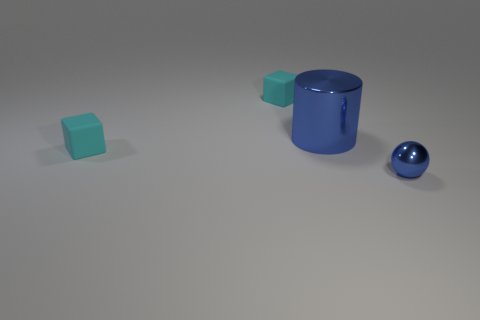How many other objects are the same material as the tiny blue thing?
Your response must be concise. 1. Is the number of blue balls that are on the left side of the tiny blue metallic sphere less than the number of large blue cylinders?
Your response must be concise. Yes. How many tiny cyan cubes are there?
Offer a terse response. 2. What number of big shiny objects are the same color as the large cylinder?
Your answer should be very brief. 0. Do the large blue metal thing and the small metallic object have the same shape?
Offer a very short reply. No. How big is the rubber block to the left of the matte object behind the blue cylinder?
Give a very brief answer. Small. Is there a matte object that has the same size as the blue sphere?
Ensure brevity in your answer.  Yes. There is a blue metallic thing behind the tiny sphere; does it have the same size as the rubber block in front of the shiny cylinder?
Give a very brief answer. No. The shiny object to the right of the metallic thing behind the tiny sphere is what shape?
Your answer should be very brief. Sphere. How many tiny blue shiny spheres are in front of the large blue cylinder?
Provide a short and direct response. 1. 